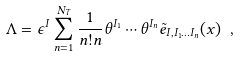<formula> <loc_0><loc_0><loc_500><loc_500>\Lambda = \epsilon ^ { I } \sum _ { n = 1 } ^ { N _ { T } } \frac { 1 } { n ! n } \theta ^ { I _ { 1 } } \cdots \theta ^ { I _ { n } } \tilde { e } _ { I , I _ { 1 } \dots I _ { n } } ( x ) \ ,</formula> 